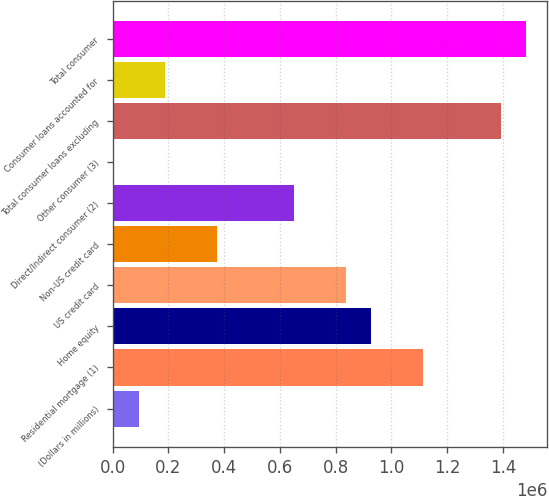Convert chart. <chart><loc_0><loc_0><loc_500><loc_500><bar_chart><fcel>(Dollars in millions)<fcel>Residential mortgage (1)<fcel>Home equity<fcel>US credit card<fcel>Non-US credit card<fcel>Direct/Indirect consumer (2)<fcel>Other consumer (3)<fcel>Total consumer loans excluding<fcel>Consumer loans accounted for<fcel>Total consumer<nl><fcel>94602.6<fcel>1.11348e+06<fcel>928233<fcel>835607<fcel>372479<fcel>650356<fcel>1977<fcel>1.39136e+06<fcel>187228<fcel>1.48399e+06<nl></chart> 